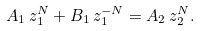Convert formula to latex. <formula><loc_0><loc_0><loc_500><loc_500>A _ { 1 } \, z _ { 1 } ^ { N } + B _ { 1 } \, z _ { 1 } ^ { - N } = A _ { 2 } \, z _ { 2 } ^ { N } .</formula> 